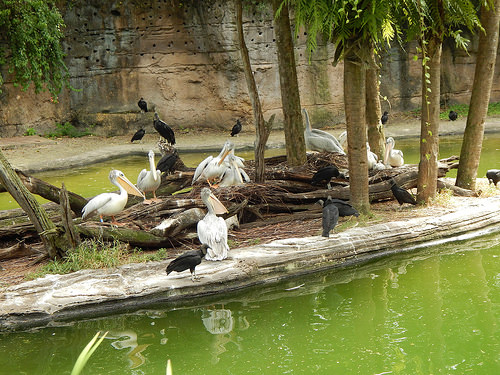<image>
Can you confirm if the bird is above the lake? Yes. The bird is positioned above the lake in the vertical space, higher up in the scene. 